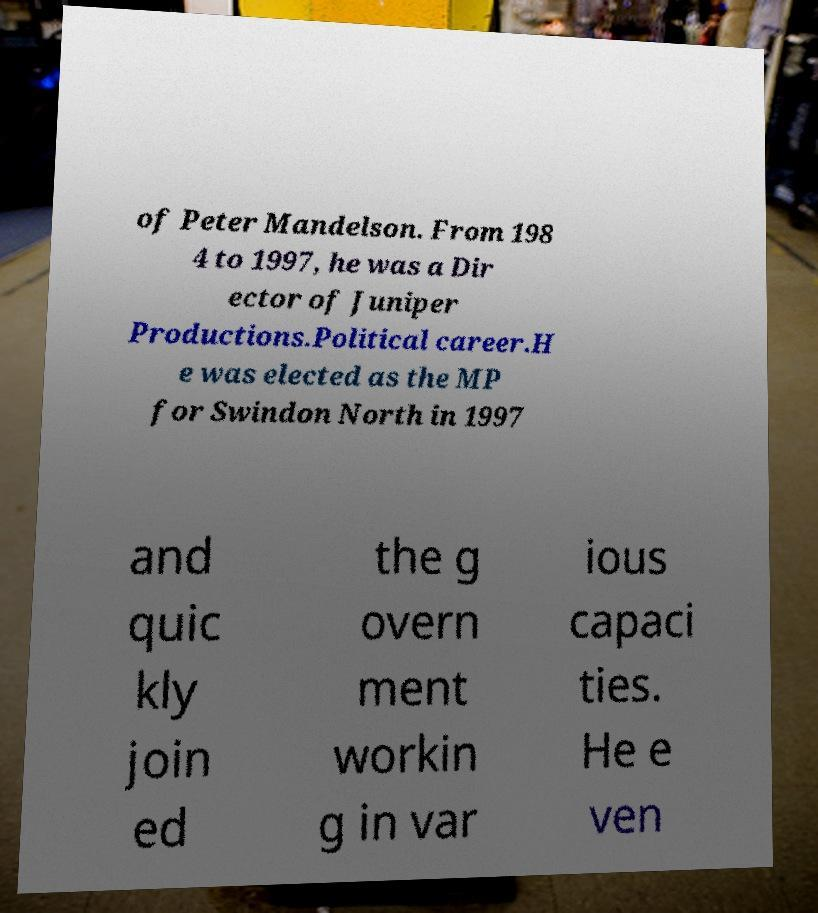Can you read and provide the text displayed in the image?This photo seems to have some interesting text. Can you extract and type it out for me? of Peter Mandelson. From 198 4 to 1997, he was a Dir ector of Juniper Productions.Political career.H e was elected as the MP for Swindon North in 1997 and quic kly join ed the g overn ment workin g in var ious capaci ties. He e ven 